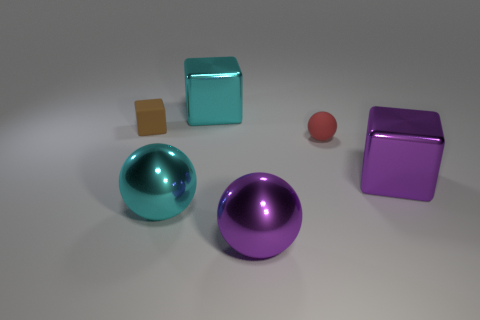Add 2 red spheres. How many objects exist? 8 Subtract 0 yellow cylinders. How many objects are left? 6 Subtract all small objects. Subtract all big things. How many objects are left? 0 Add 1 tiny red rubber balls. How many tiny red rubber balls are left? 2 Add 6 cyan metal things. How many cyan metal things exist? 8 